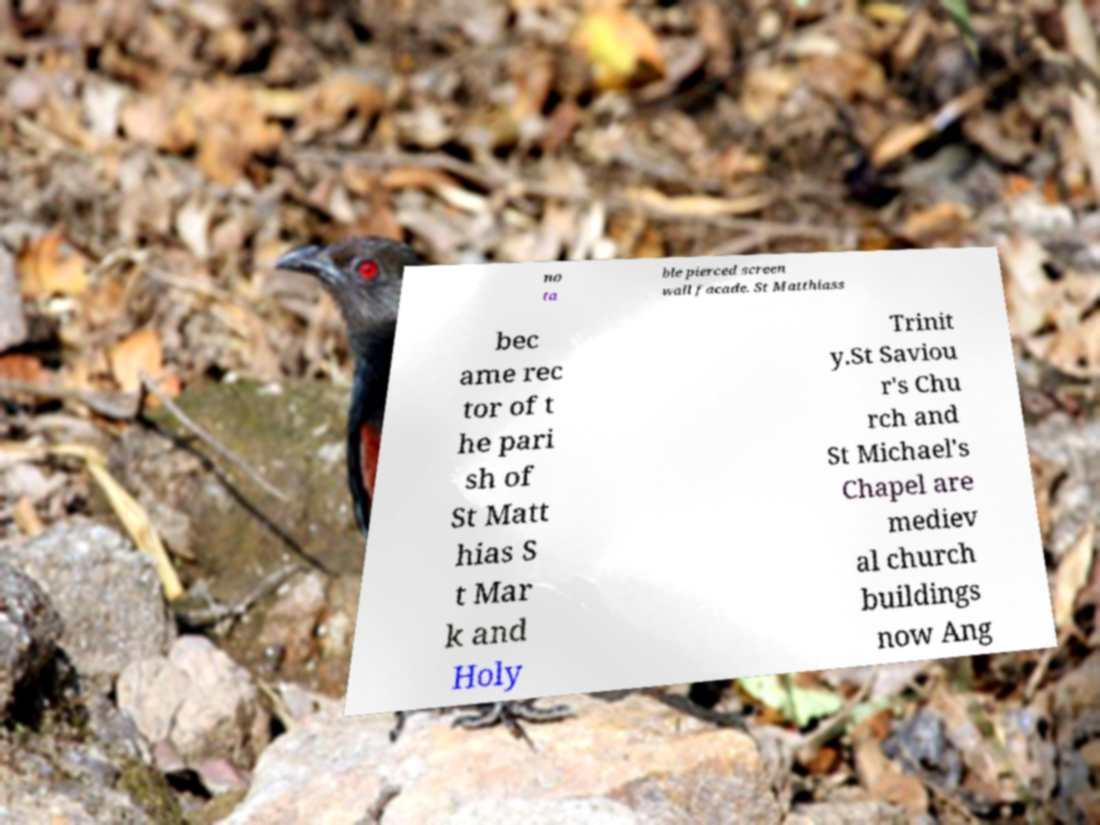Could you assist in decoding the text presented in this image and type it out clearly? no ta ble pierced screen wall facade. St Matthiass bec ame rec tor of t he pari sh of St Matt hias S t Mar k and Holy Trinit y.St Saviou r's Chu rch and St Michael's Chapel are mediev al church buildings now Ang 